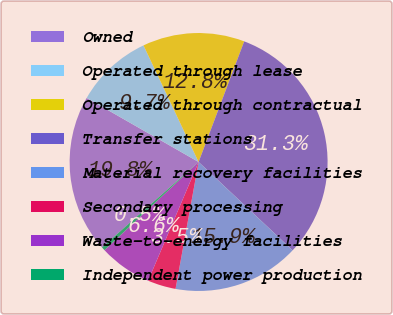<chart> <loc_0><loc_0><loc_500><loc_500><pie_chart><fcel>Owned<fcel>Operated through lease<fcel>Operated through contractual<fcel>Transfer stations<fcel>Material recovery facilities<fcel>Secondary processing<fcel>Waste-to-energy facilities<fcel>Independent power production<nl><fcel>19.8%<fcel>9.7%<fcel>12.78%<fcel>31.26%<fcel>15.86%<fcel>3.54%<fcel>6.62%<fcel>0.46%<nl></chart> 